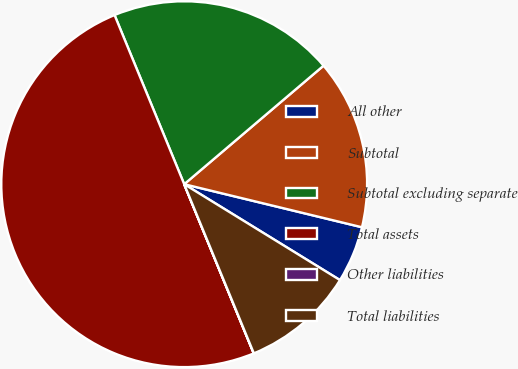<chart> <loc_0><loc_0><loc_500><loc_500><pie_chart><fcel>All other<fcel>Subtotal<fcel>Subtotal excluding separate<fcel>Total assets<fcel>Other liabilities<fcel>Total liabilities<nl><fcel>5.0%<fcel>15.0%<fcel>20.0%<fcel>49.99%<fcel>0.01%<fcel>10.0%<nl></chart> 